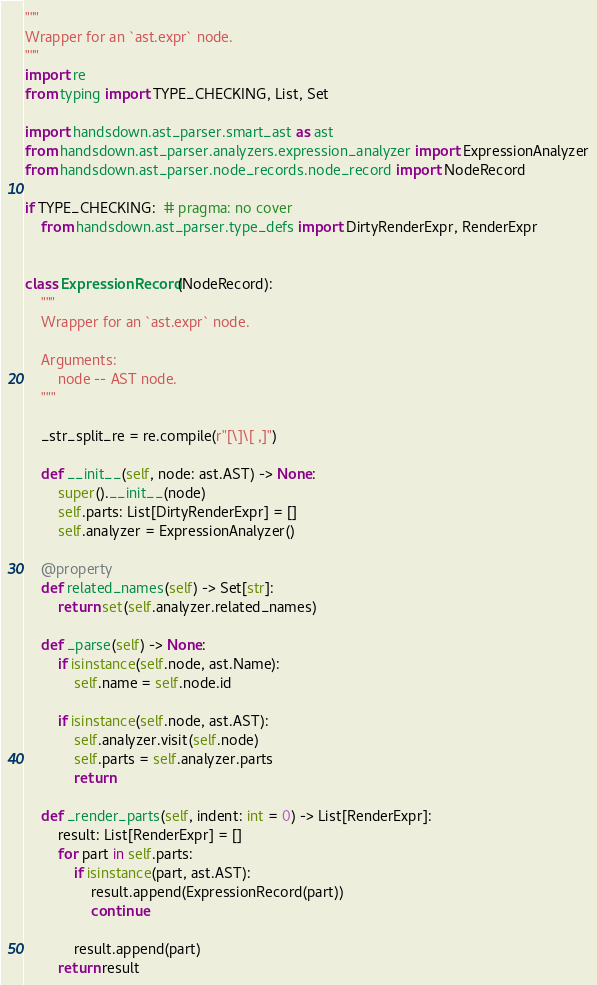Convert code to text. <code><loc_0><loc_0><loc_500><loc_500><_Python_>"""
Wrapper for an `ast.expr` node.
"""
import re
from typing import TYPE_CHECKING, List, Set

import handsdown.ast_parser.smart_ast as ast
from handsdown.ast_parser.analyzers.expression_analyzer import ExpressionAnalyzer
from handsdown.ast_parser.node_records.node_record import NodeRecord

if TYPE_CHECKING:  # pragma: no cover
    from handsdown.ast_parser.type_defs import DirtyRenderExpr, RenderExpr


class ExpressionRecord(NodeRecord):
    """
    Wrapper for an `ast.expr` node.

    Arguments:
        node -- AST node.
    """

    _str_split_re = re.compile(r"[\]\[ ,]")

    def __init__(self, node: ast.AST) -> None:
        super().__init__(node)
        self.parts: List[DirtyRenderExpr] = []
        self.analyzer = ExpressionAnalyzer()

    @property
    def related_names(self) -> Set[str]:
        return set(self.analyzer.related_names)

    def _parse(self) -> None:
        if isinstance(self.node, ast.Name):
            self.name = self.node.id

        if isinstance(self.node, ast.AST):
            self.analyzer.visit(self.node)
            self.parts = self.analyzer.parts
            return

    def _render_parts(self, indent: int = 0) -> List[RenderExpr]:
        result: List[RenderExpr] = []
        for part in self.parts:
            if isinstance(part, ast.AST):
                result.append(ExpressionRecord(part))
                continue

            result.append(part)
        return result
</code> 